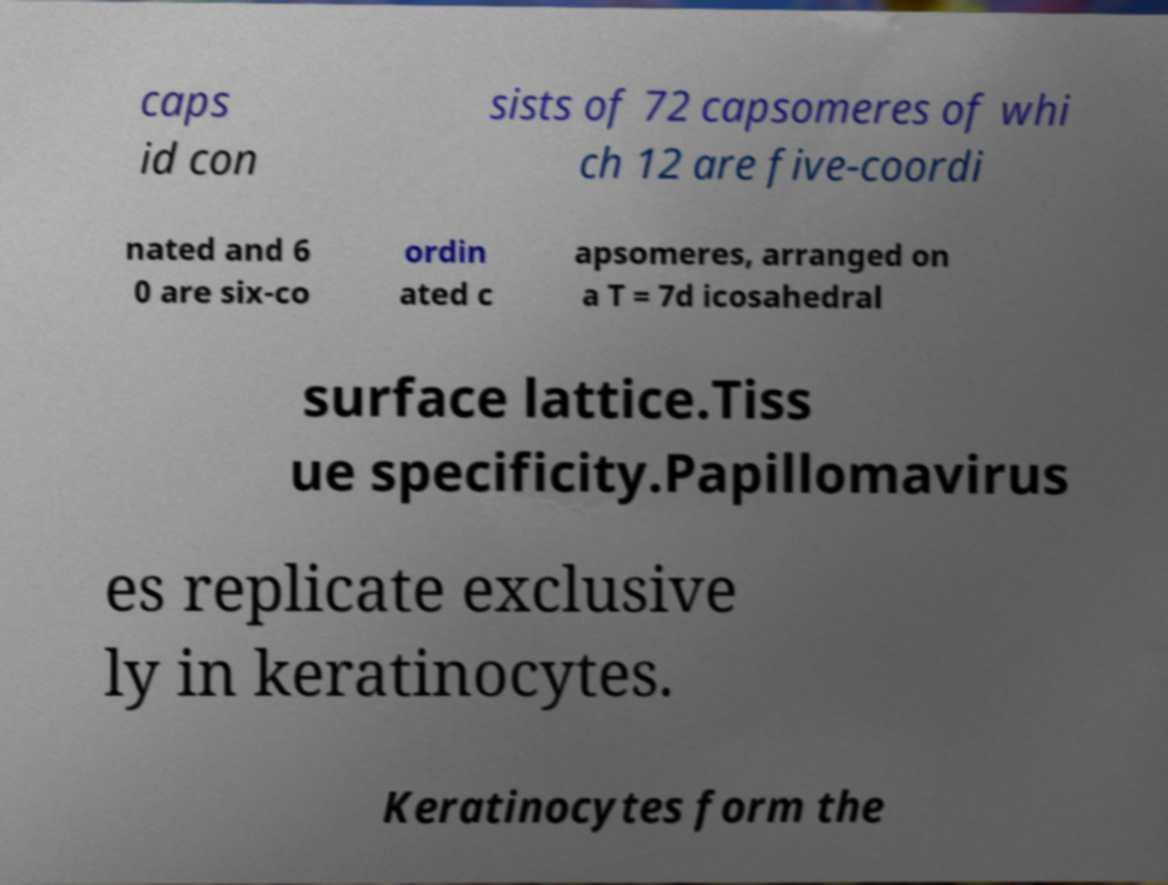There's text embedded in this image that I need extracted. Can you transcribe it verbatim? caps id con sists of 72 capsomeres of whi ch 12 are five-coordi nated and 6 0 are six-co ordin ated c apsomeres, arranged on a T = 7d icosahedral surface lattice.Tiss ue specificity.Papillomavirus es replicate exclusive ly in keratinocytes. Keratinocytes form the 